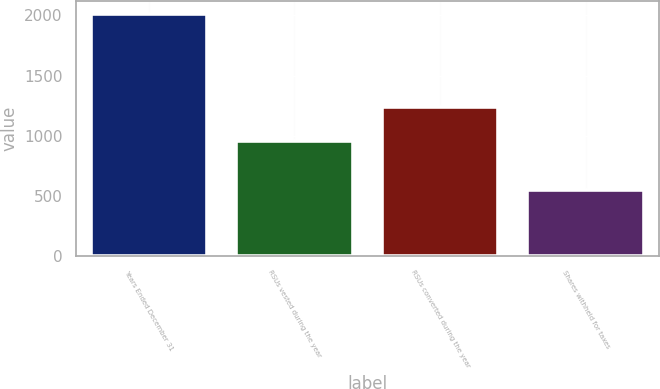Convert chart to OTSL. <chart><loc_0><loc_0><loc_500><loc_500><bar_chart><fcel>Years Ended December 31<fcel>RSUs vested during the year<fcel>RSUs converted during the year<fcel>Shares withheld for taxes<nl><fcel>2015<fcel>954<fcel>1238<fcel>549<nl></chart> 